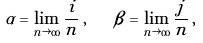Convert formula to latex. <formula><loc_0><loc_0><loc_500><loc_500>\alpha = \lim _ { n \rightarrow \infty } \frac { i } { n } \, , \quad \beta = \lim _ { n \rightarrow \infty } \frac { j } { n } \, ,</formula> 